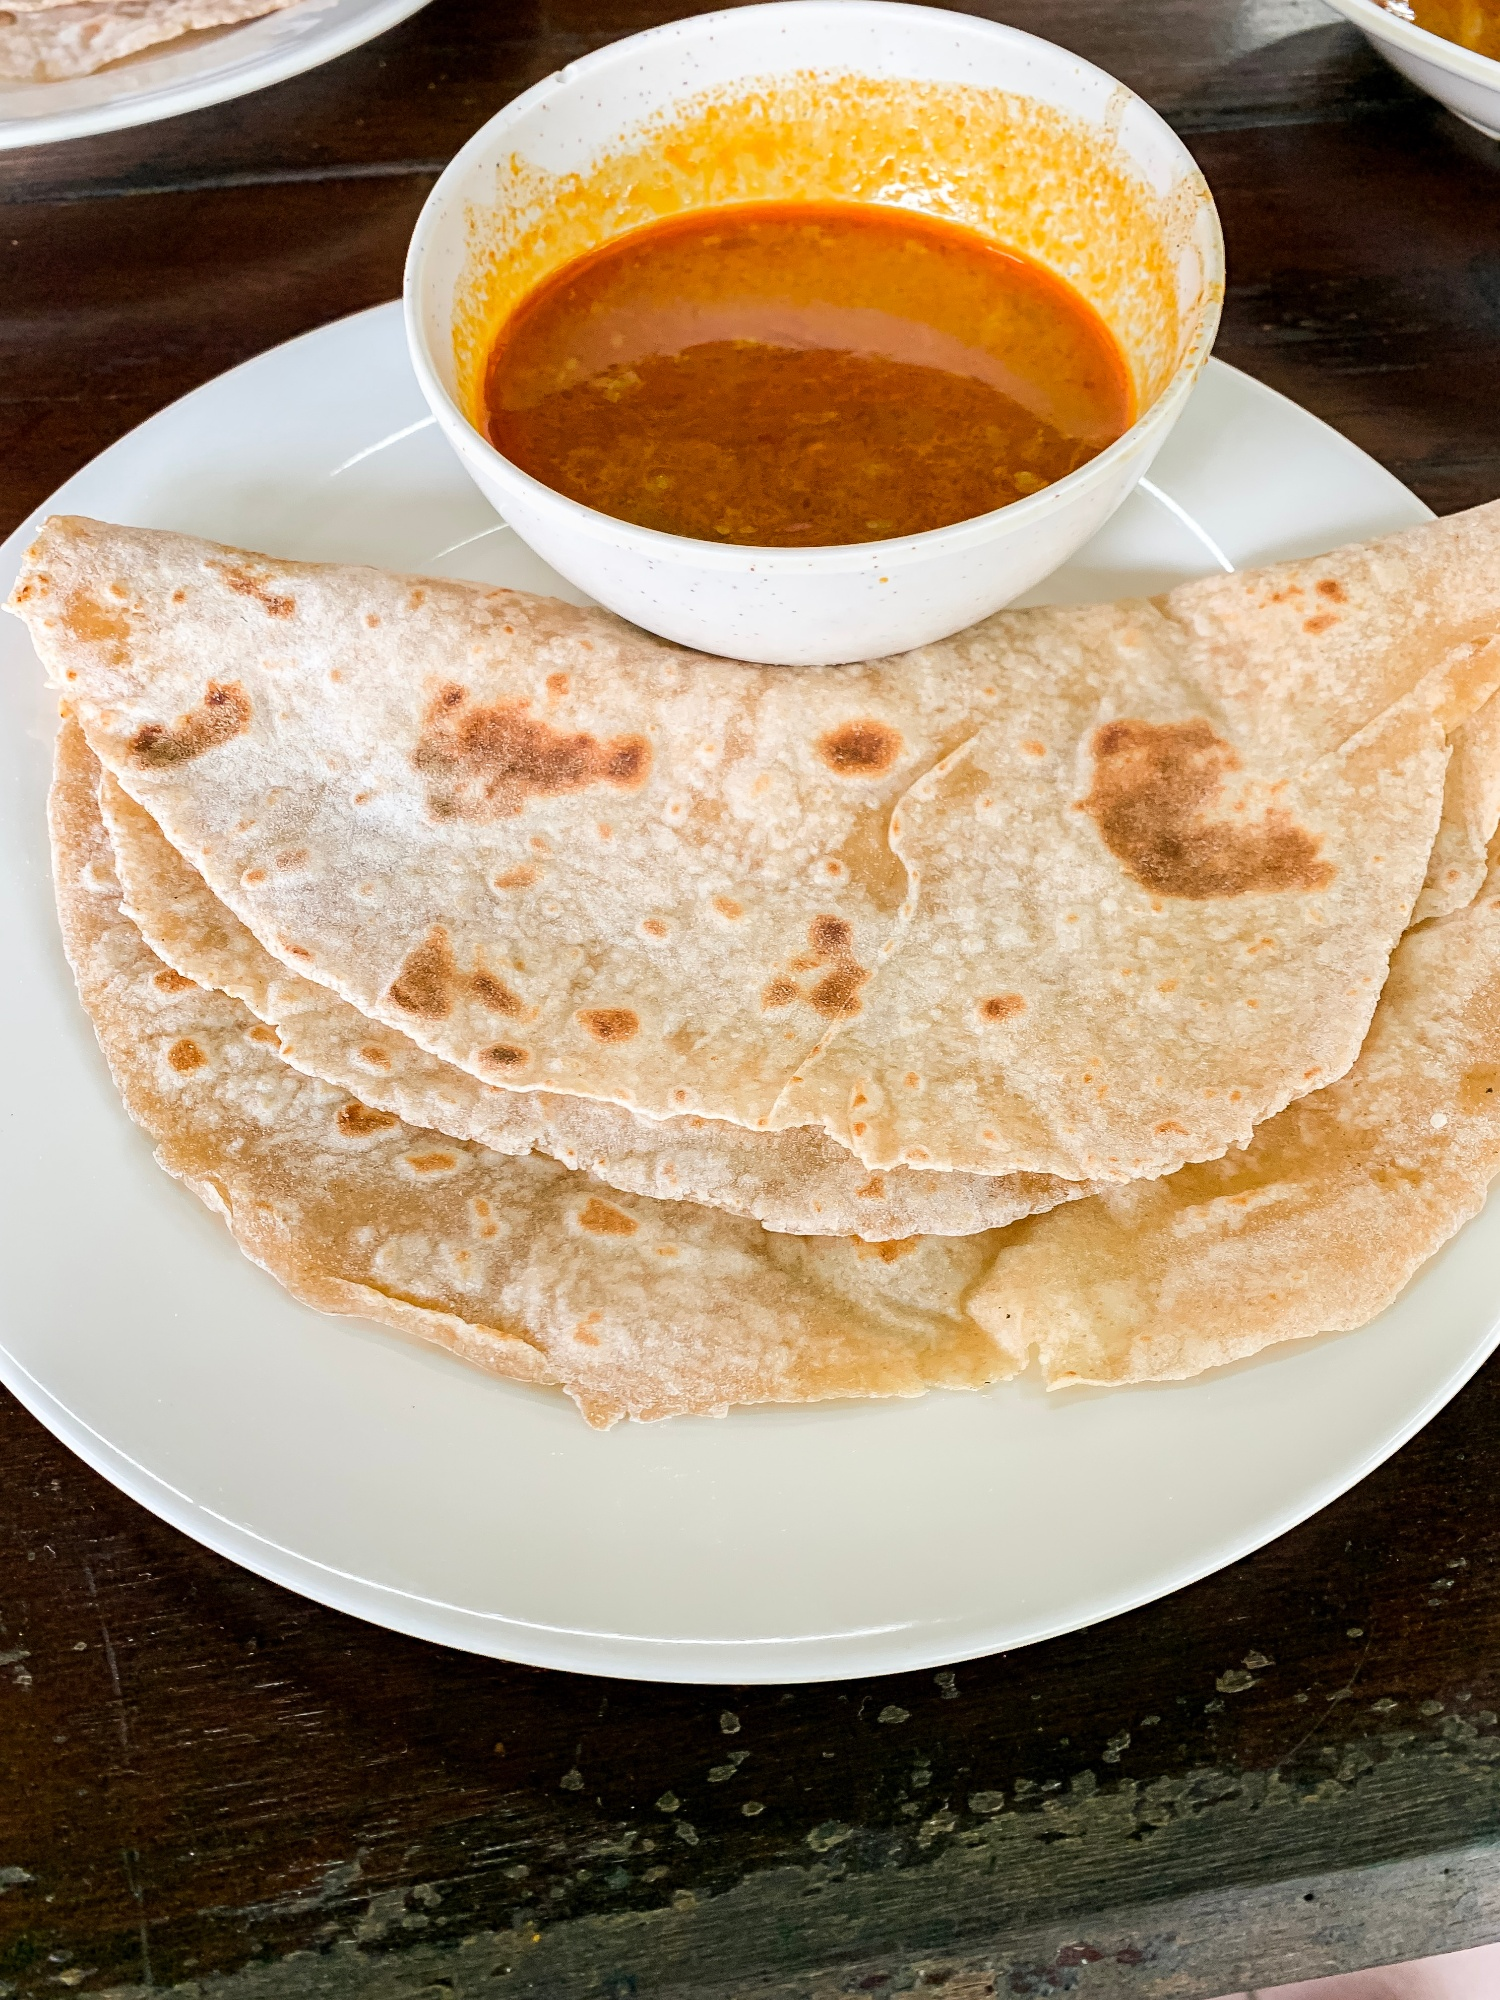What do you think is going on in this snapshot? This image showcases a delicious and simple meal from Indian cuisine. In the foreground, you can see a neatly folded, stack of rotis, a type of soft, round Indian bread made from whole wheat flour, placed on a white plate. On the side, there's a small bowl filled with a vibrant orange curry, likely rich in spices and flavors, reflecting a traditional Indian dish. The curry's color indicates the use of spices such as turmeric, red chili powder, and perhaps creamy elements like coconut milk or yogurt. The top-down perspective of the photograph enhances the visual appeal by highlighting the textures of the roti and the contrasting vibrancy of the curry, capturing the essence of a balanced and flavorful meal. This image not only presents food but also an aspect of cultural culinary practice, inviting one to appreciate the simplicity and depth of Indian cuisine. 